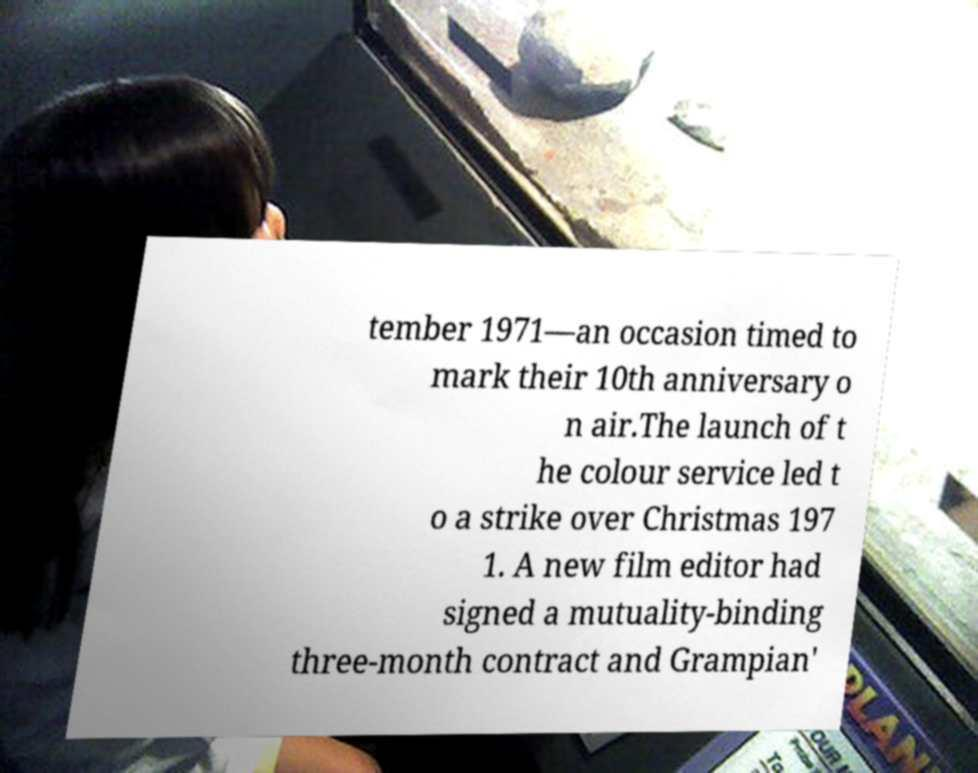For documentation purposes, I need the text within this image transcribed. Could you provide that? tember 1971—an occasion timed to mark their 10th anniversary o n air.The launch of t he colour service led t o a strike over Christmas 197 1. A new film editor had signed a mutuality-binding three-month contract and Grampian' 